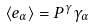Convert formula to latex. <formula><loc_0><loc_0><loc_500><loc_500>\langle e _ { \alpha } \rangle = P ^ { \gamma } \gamma _ { \alpha }</formula> 